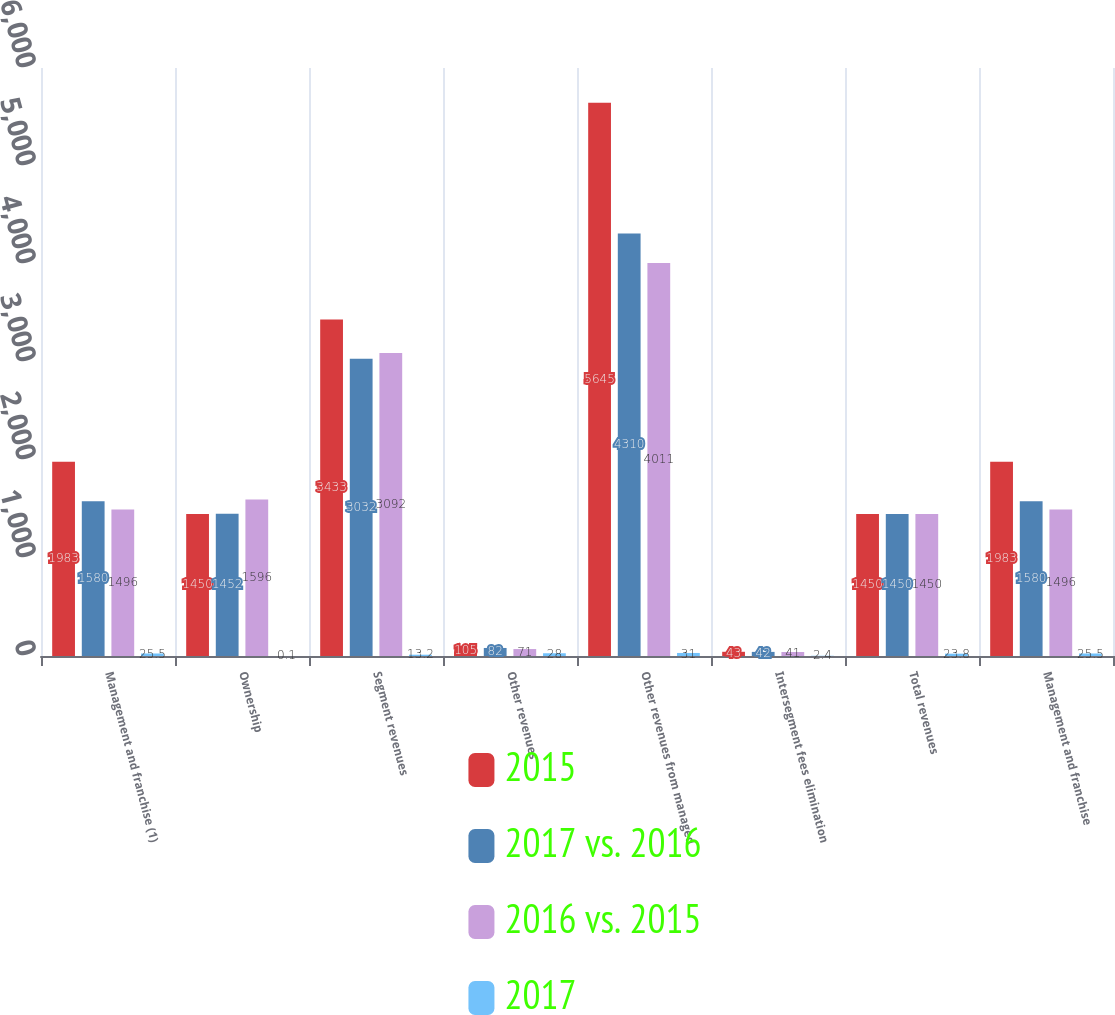Convert chart. <chart><loc_0><loc_0><loc_500><loc_500><stacked_bar_chart><ecel><fcel>Management and franchise (1)<fcel>Ownership<fcel>Segment revenues<fcel>Other revenues<fcel>Other revenues from managed<fcel>Intersegment fees elimination<fcel>Total revenues<fcel>Management and franchise<nl><fcel>2015<fcel>1983<fcel>1450<fcel>3433<fcel>105<fcel>5645<fcel>43<fcel>1450<fcel>1983<nl><fcel>2017 vs. 2016<fcel>1580<fcel>1452<fcel>3032<fcel>82<fcel>4310<fcel>42<fcel>1450<fcel>1580<nl><fcel>2016 vs. 2015<fcel>1496<fcel>1596<fcel>3092<fcel>71<fcel>4011<fcel>41<fcel>1450<fcel>1496<nl><fcel>2017<fcel>25.5<fcel>0.1<fcel>13.2<fcel>28<fcel>31<fcel>2.4<fcel>23.8<fcel>25.5<nl></chart> 